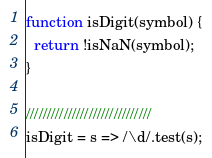Convert code to text. <code><loc_0><loc_0><loc_500><loc_500><_JavaScript_>function isDigit(symbol) {
  return !isNaN(symbol);
}

//////////////////////////////
isDigit = s => /\d/.test(s);
</code> 